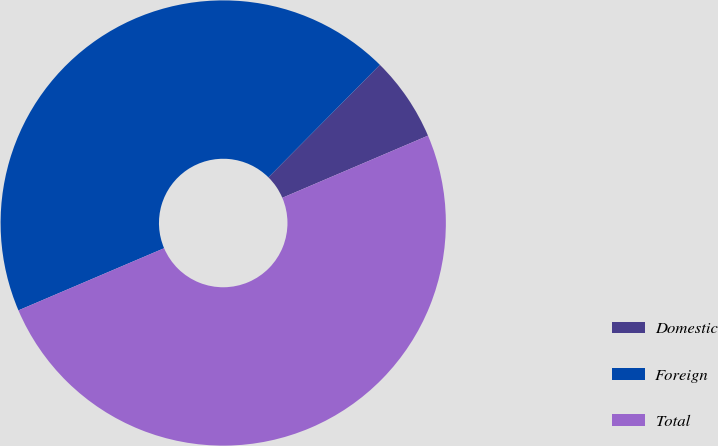Convert chart. <chart><loc_0><loc_0><loc_500><loc_500><pie_chart><fcel>Domestic<fcel>Foreign<fcel>Total<nl><fcel>6.16%<fcel>43.84%<fcel>50.0%<nl></chart> 